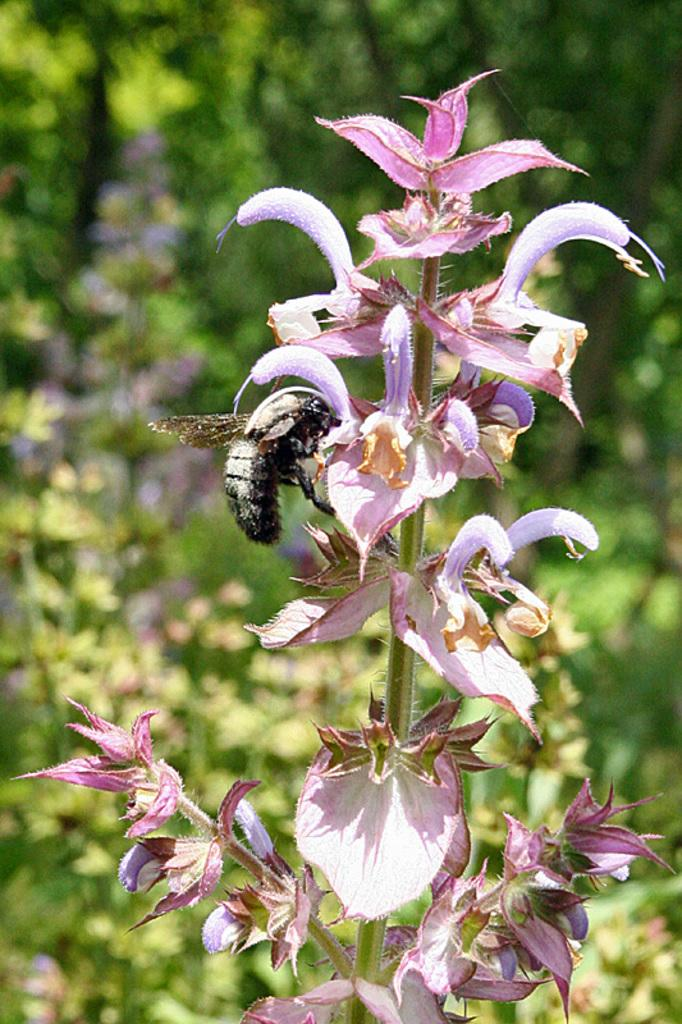What type of living organism can be seen in the image? There is an insect in the image. What other natural elements are present in the image? There are plants with flowers in the image. What can be seen in the background of the image? There are trees in the background of the image. How would you describe the clarity of the image? The image is blurry. What type of sack is the crook carrying in the image? There is no crook or sack present in the image; it features an insect and plants with flowers. 